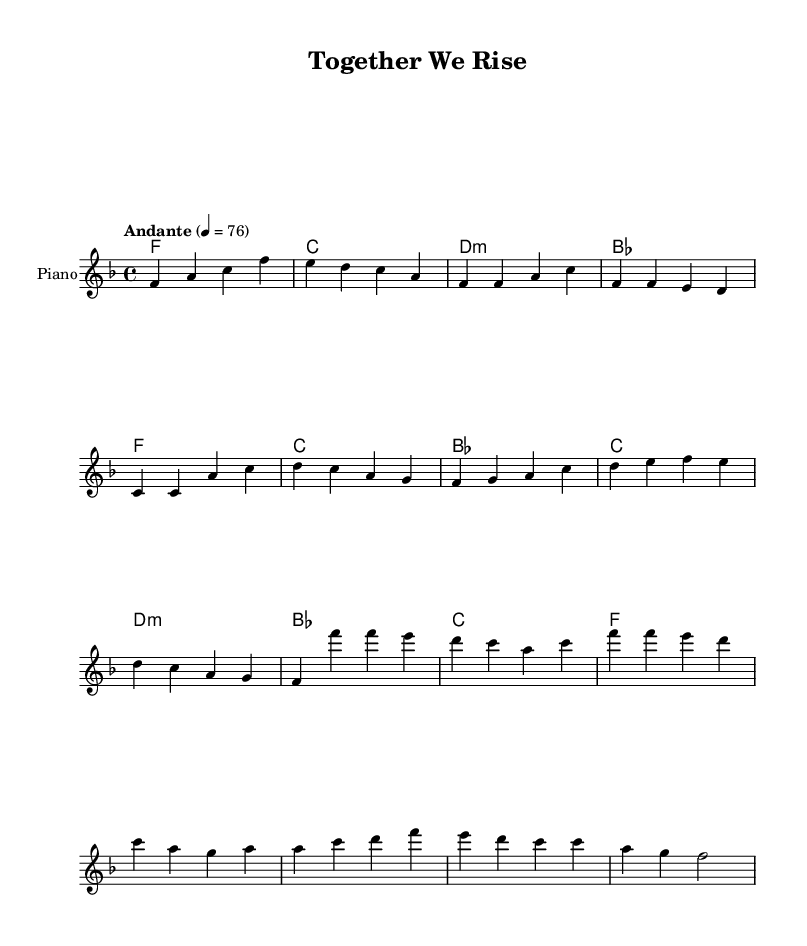What is the key signature of this music? The key signature is F major, which has one flat (B flat). This can be identified from the key signature shown at the beginning of the staff.
Answer: F major What is the time signature of this piece? The time signature is 4/4, which means there are four beats in each measure and a quarter note gets one beat. This is indicated at the beginning of the score.
Answer: 4/4 What is the tempo marking for this music? The tempo marking is "Andante" with a metronome marking of 76 beats per minute, which indicates a moderately slow tempo. This is specified at the start of the score.
Answer: Andante, 76 How many measures are in the chorus section? The chorus section consists of four measures, as can be counted from the notated melody and chords labeled "Chorus."
Answer: 4 What type of harmonies are used in the piece? The piece uses common triadic harmonies, typical in K-Pop, such as F, C, D minor, and B flat, as shown in the chord names. This reflects a typical K-Pop harmonic structure emphasizing emotional impact.
Answer: Triadic harmonies How does the structure of this song reflect K-Pop characteristics? The song follows a traditional pop structure with clear sections such as verses, pre-choruses, and choruses. This repetitive and emotional build-up is characteristic of K-Pop, allowing for both lyrical storytelling and musical catchiness.
Answer: Traditional pop structure What is the main theme expressed in the lyrics of this song? The main theme expressed in the lyrics is unity and strength through collective action, reflecting a message of hope and resilience, which aligns with common K-Pop themes of empowerment.
Answer: Unity and strength 